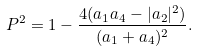<formula> <loc_0><loc_0><loc_500><loc_500>P ^ { 2 } = 1 - \frac { 4 ( a _ { 1 } a _ { 4 } - | a _ { 2 } | ^ { 2 } ) } { ( a _ { 1 } + a _ { 4 } ) ^ { 2 } } .</formula> 